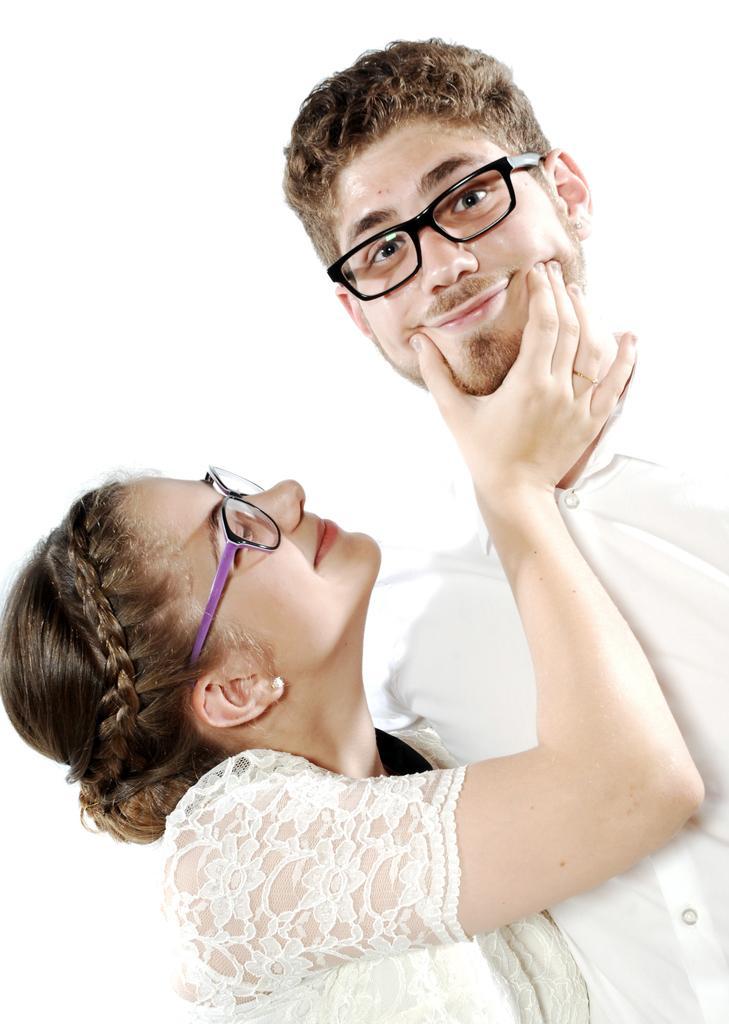Can you describe this image briefly? This is the man and woman smiling. They wore spectacles. The background looks white in color. 